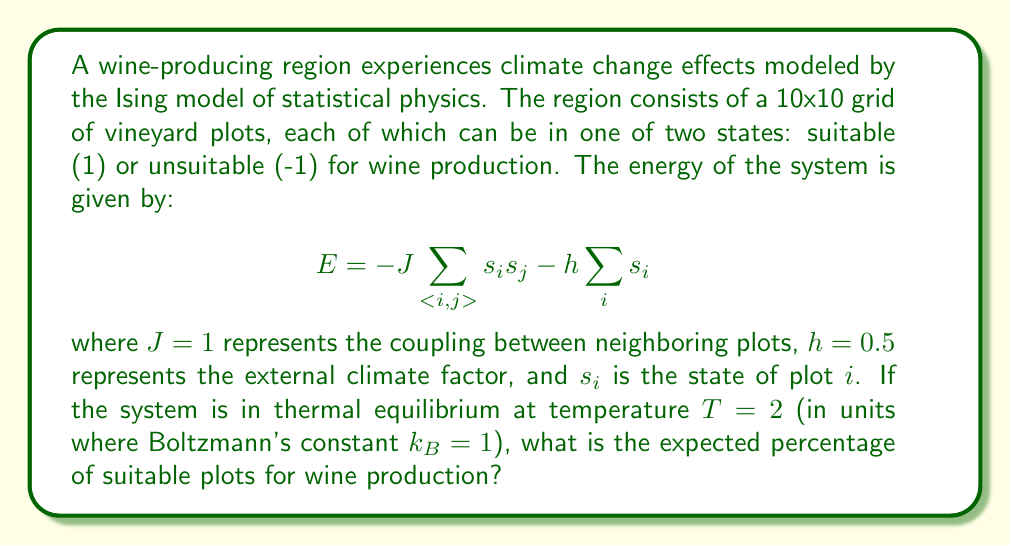Could you help me with this problem? To solve this problem, we'll use the mean-field approximation of the Ising model:

1. The mean-field equation for the average spin (magnetization) $m$ is:

   $$m = \tanh(\beta(Jqm + h))$$

   where $\beta = \frac{1}{k_BT}$, and $q$ is the number of nearest neighbors (4 for a 2D square lattice).

2. Substitute the given values:
   $J = 1$, $h = 0.5$, $T = 2$, $k_B = 1$, $q = 4$

3. Calculate $\beta$:
   $$\beta = \frac{1}{k_BT} = \frac{1}{1 \cdot 2} = 0.5$$

4. The mean-field equation becomes:

   $$m = \tanh(0.5(4m + 0.5))$$

5. Solve this equation numerically (e.g., using Newton's method):

   $$m \approx 0.6645$$

6. The magnetization $m$ represents the average spin. In our case, it represents the average state of the plots.

7. To convert this to a percentage of suitable plots:
   
   Percentage = $\frac{m + 1}{2} \cdot 100\%$

8. Calculate the final percentage:

   Percentage = $\frac{0.6645 + 1}{2} \cdot 100\% \approx 83.22\%$
Answer: 83.22% 